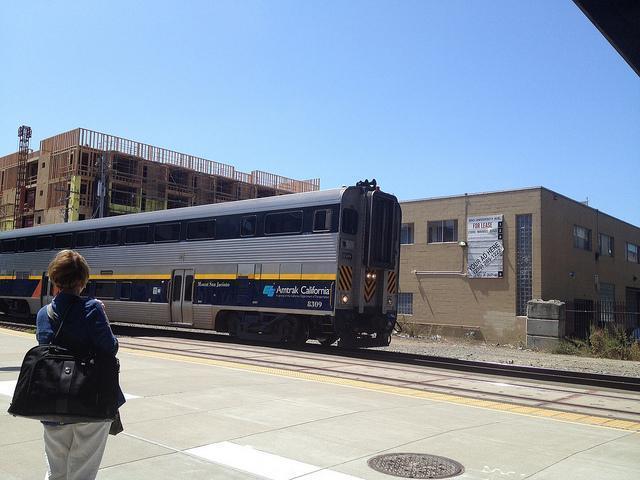How many people are in this photo?
Give a very brief answer. 1. How many color umbrellas are there in the image ?
Give a very brief answer. 0. 